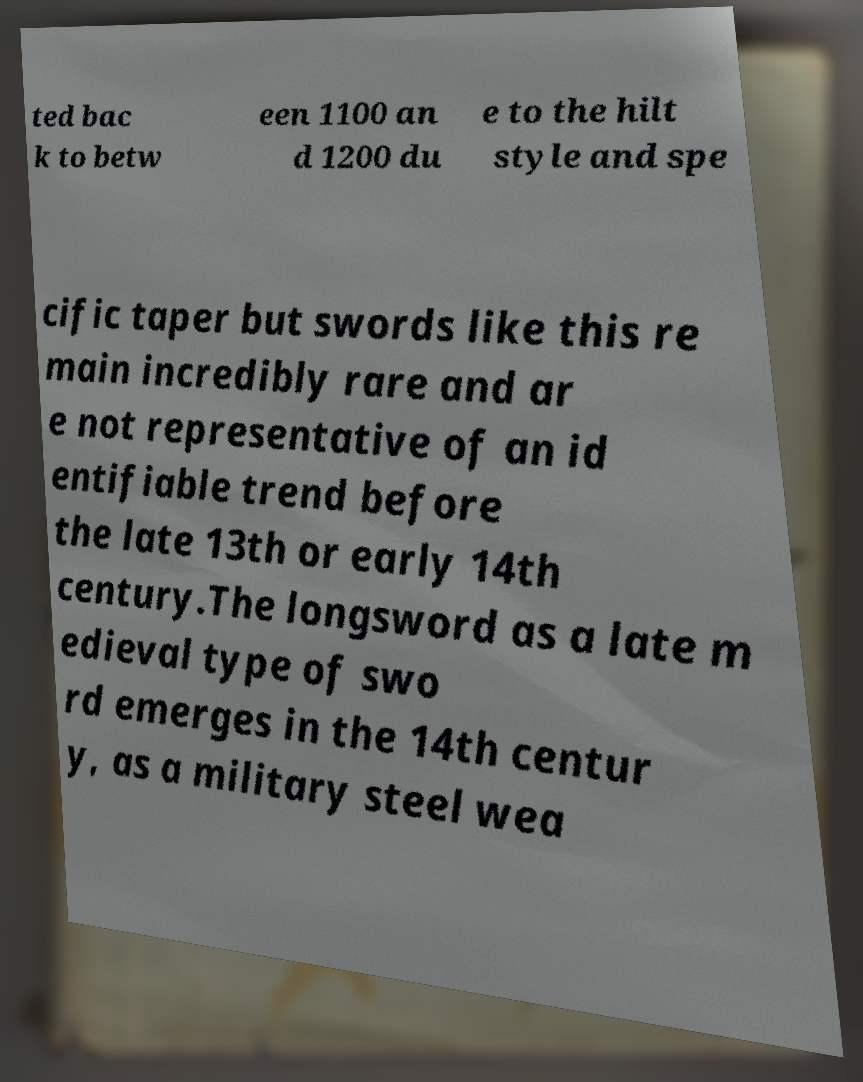Can you read and provide the text displayed in the image?This photo seems to have some interesting text. Can you extract and type it out for me? ted bac k to betw een 1100 an d 1200 du e to the hilt style and spe cific taper but swords like this re main incredibly rare and ar e not representative of an id entifiable trend before the late 13th or early 14th century.The longsword as a late m edieval type of swo rd emerges in the 14th centur y, as a military steel wea 